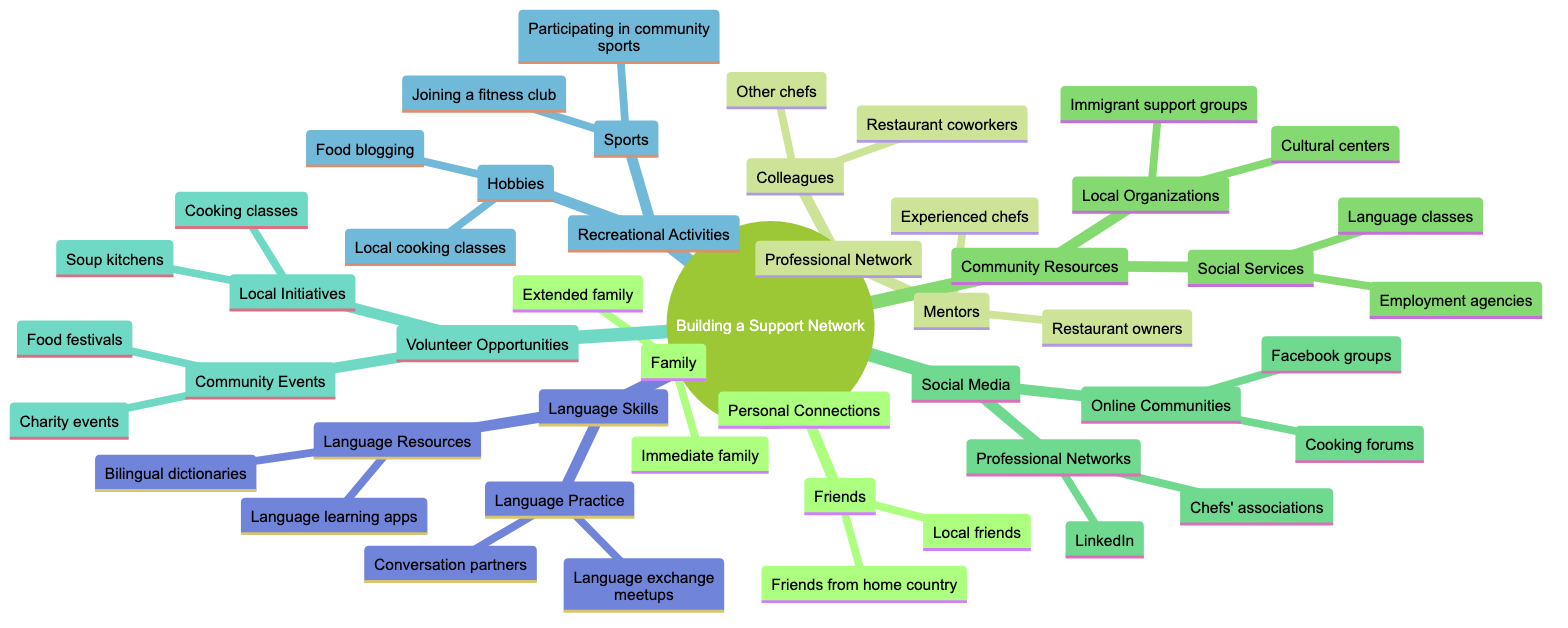What are two types of personal connections mentioned? The diagram identifies two categories of personal connections: "Friends" and "Family." Both these categories include various subtypes, but the question specifically asks for the types themselves.
Answer: Friends, Family How many types of community resources are there? The diagram shows two main categories under community resources: "Local Organizations" and "Social Services," thus indicating two distinct types in total.
Answer: 2 What are two types of recreational activities listed? The diagram presents two categories under recreational activities: "Hobbies" and "Sports." Each of these categories encompasses various subtypes, but the question asks specifically for the types.
Answer: Hobbies, Sports Which online community platforms are included in the social media section? The social media section of the diagram includes "Facebook groups" and "Cooking forums" as the two specific examples listed under online communities.
Answer: Facebook groups, Cooking forums How many types of language skills are represented in the diagram? The diagram indicates that there are two categories related to language skills: "Language Practice" and "Language Resources," hence the total number of types represented is two.
Answer: 2 Which professional network is specifically mentioned in the diagram? "LinkedIn" is specifically mentioned as one of the platforms under professional networks in the social media section of the diagram.
Answer: LinkedIn What types of local initiatives are suggested under volunteer opportunities? The volunteer opportunities section lists two types of local initiatives: "Soup kitchens" and "Cooking classes." Both are examples of how one can engage in community service.
Answer: Soup kitchens, Cooking classes What is one way to develop language skills mentioned in the diagram? The diagram highlights "Conversation partners" as one method to improve language skills, which falls under the "Language Practice" category.
Answer: Conversation partners Which category includes "Food festivals"? "Community Events" within the "Volunteer Opportunities" section contains "Food festivals" as one of its specific examples of engagement opportunities.
Answer: Community Events 